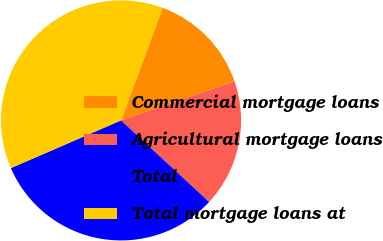Convert chart to OTSL. <chart><loc_0><loc_0><loc_500><loc_500><pie_chart><fcel>Commercial mortgage loans<fcel>Agricultural mortgage loans<fcel>Total<fcel>Total mortgage loans at<nl><fcel>14.1%<fcel>17.16%<fcel>31.61%<fcel>37.13%<nl></chart> 